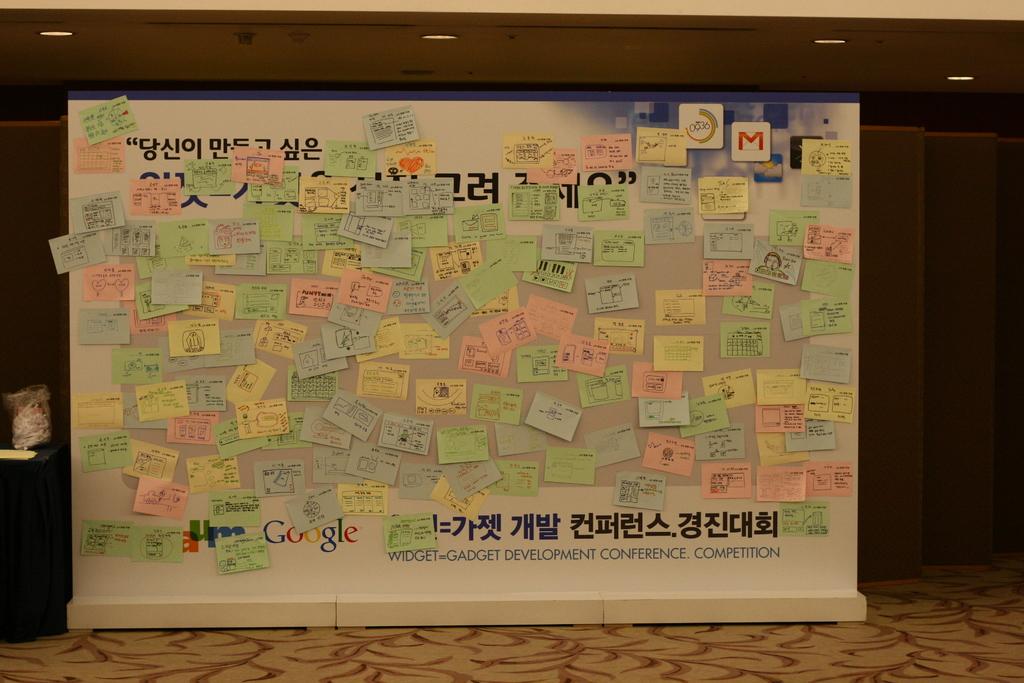What is one of the popular brands on this large board?
Ensure brevity in your answer.  Google. What kind of competition is this?
Offer a terse response. Gadget development. 